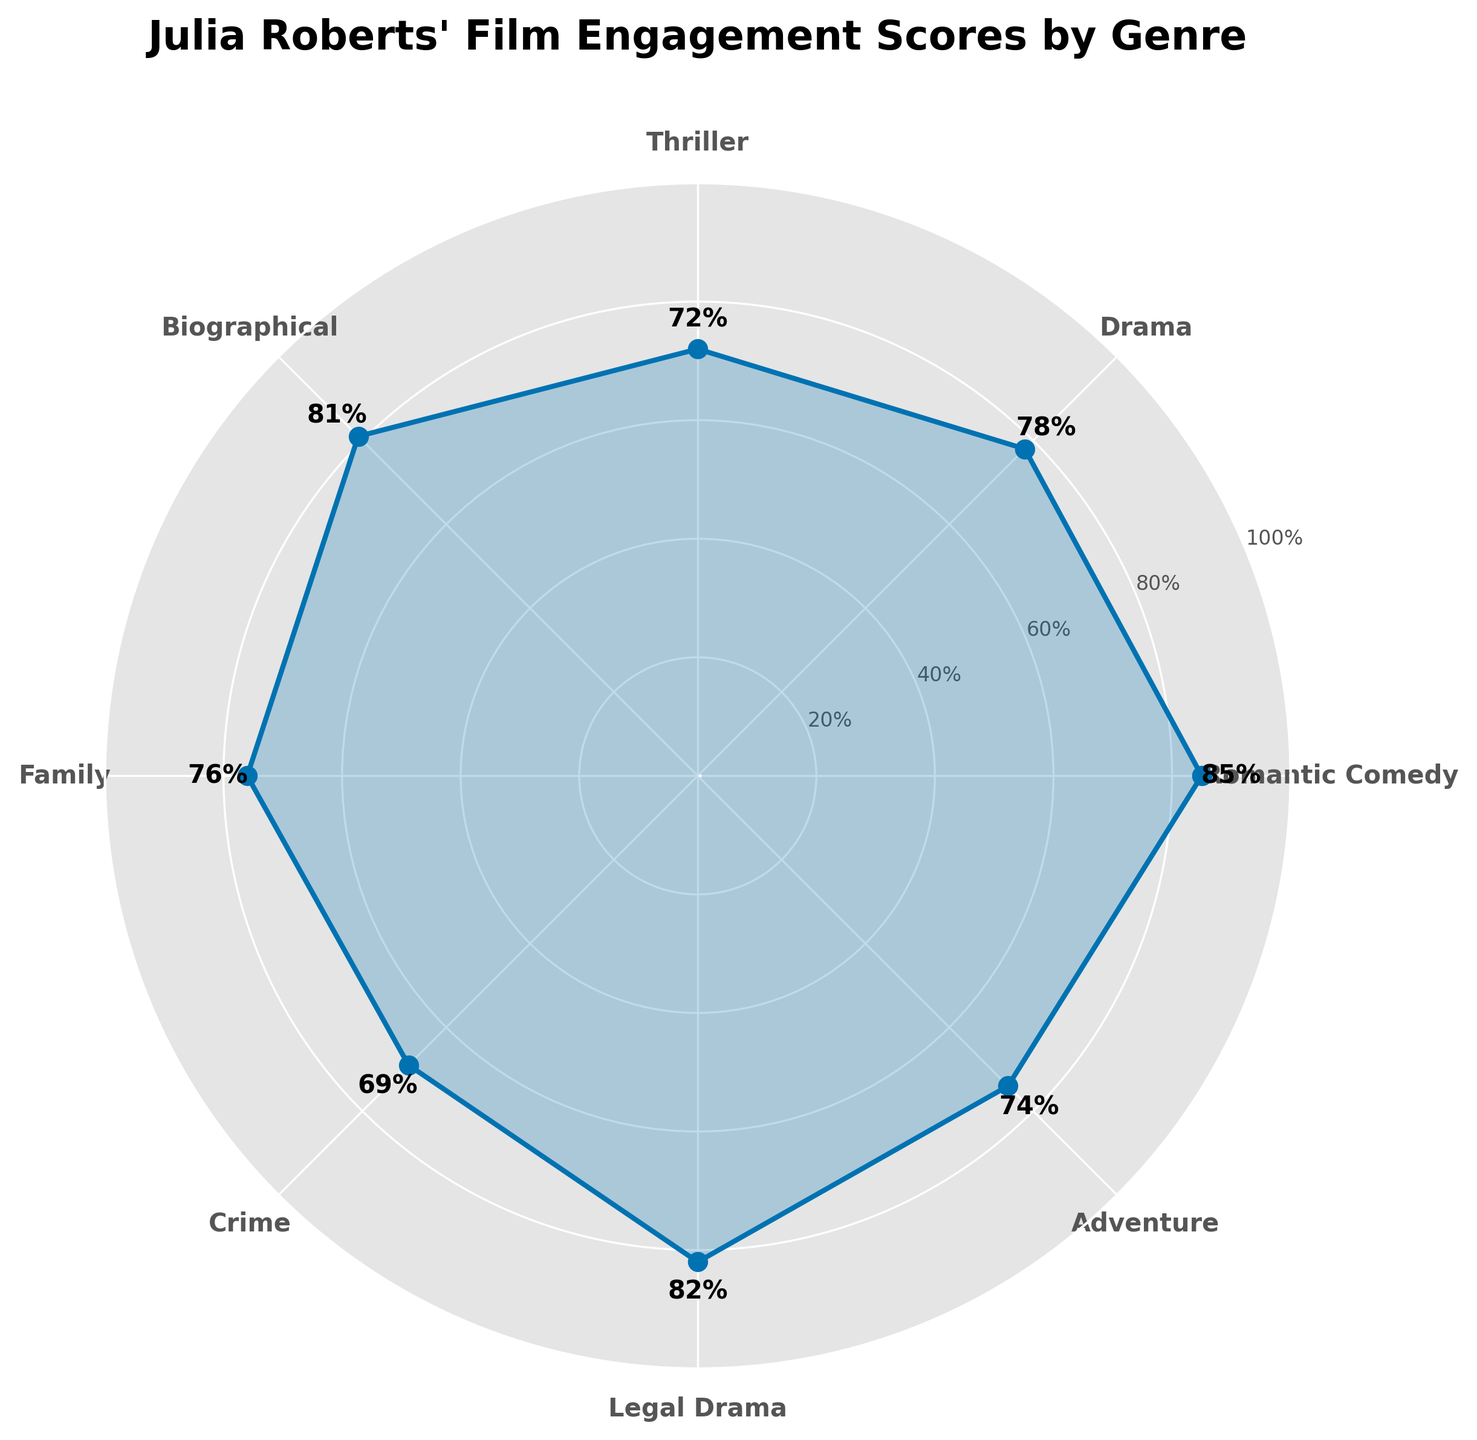How many genres are represented in the figure? There are 8 data points or genres plotted on the polar chart. Each point on the outer ring corresponds to a different genre, as indicated by the labels around the circle.
Answer: 8 Which genre has the highest audience engagement score? Looking at the values displayed on the plot, the genre with the highest engagement score is the Romantic Comedy, which has a score of 85%.
Answer: Romantic Comedy What is the engagement score for the genre Adventure? On the polar chart, find the label 'Adventure' and then look at the value or point associated with it. The engagement score for Adventure is displayed as 74%.
Answer: 74 How does the engagement score for Family compare to that for Thriller? Check the engagement scores for both Family and Thriller on the chart. Family has a score of 76%, while Thriller has a score of 72%. Family has a higher engagement score compared to Thriller.
Answer: Family has a higher score What is the difference in engagement scores between Drama and Crime genres? Locate the engagement scores for both Drama (78%) and Crime (69%) on the chart. Subtract the smaller score from the larger score to find the difference: 78% - 69% = 9%.
Answer: 9% Which two genres have engagement scores that are closest to each other? Examine the differences between the engagement scores of adjacent genres. The closest engagement scores are for Family (76%) and Drama (78%), which differ by only 2%.
Answer: Family and Drama What is the average engagement score across all the genres? Add up all the engagement scores: 85 + 78 + 72 + 81 + 76 + 69 + 82 + 74 = 617. Then, divide by the number of genres (8): 617 / 8 = 77.125%.
Answer: 77.125% Which genre shows the second highest engagement score? First identify the highest (Romantic Comedy, 85%), then locate the second highest. The second highest engagement score is for the genre 'Legal Drama' with 82%.
Answer: Legal Drama What is the title displayed on the figure? The title is prominently displayed at the top-center of the polar chart and reads "Julia Roberts' Film Engagement Scores by Genre".
Answer: Julia Roberts' Film Engagement Scores by Genre 